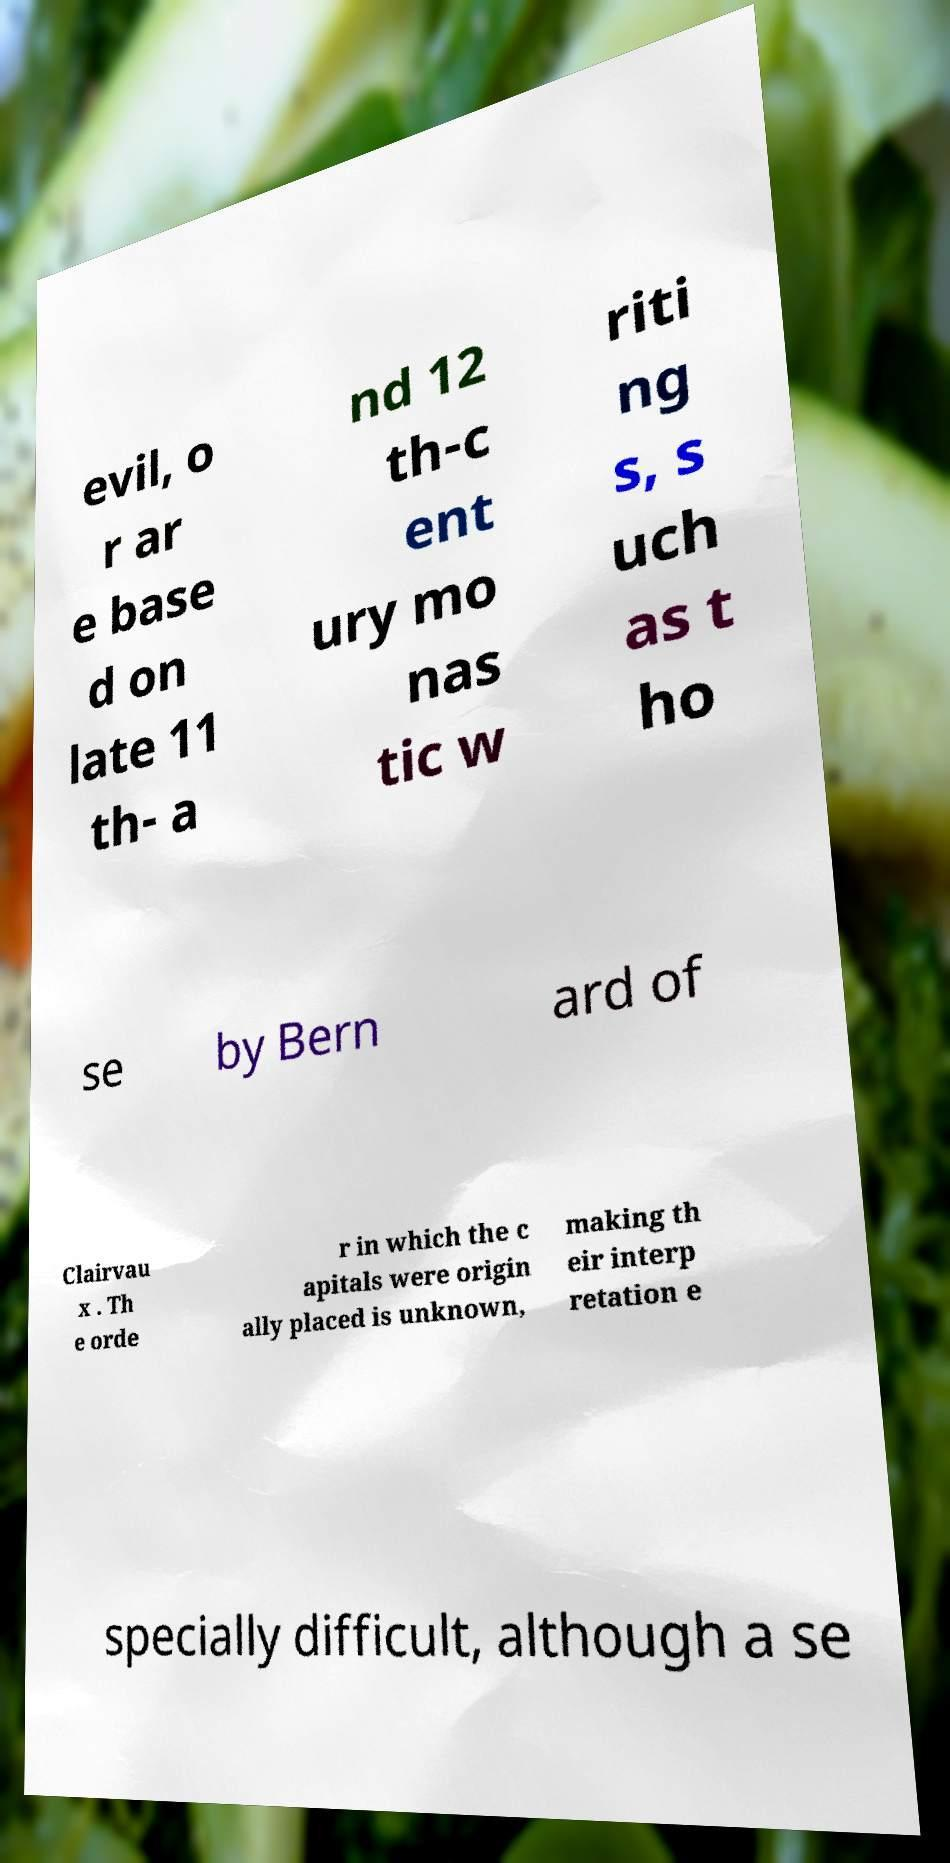For documentation purposes, I need the text within this image transcribed. Could you provide that? evil, o r ar e base d on late 11 th- a nd 12 th-c ent ury mo nas tic w riti ng s, s uch as t ho se by Bern ard of Clairvau x . Th e orde r in which the c apitals were origin ally placed is unknown, making th eir interp retation e specially difficult, although a se 